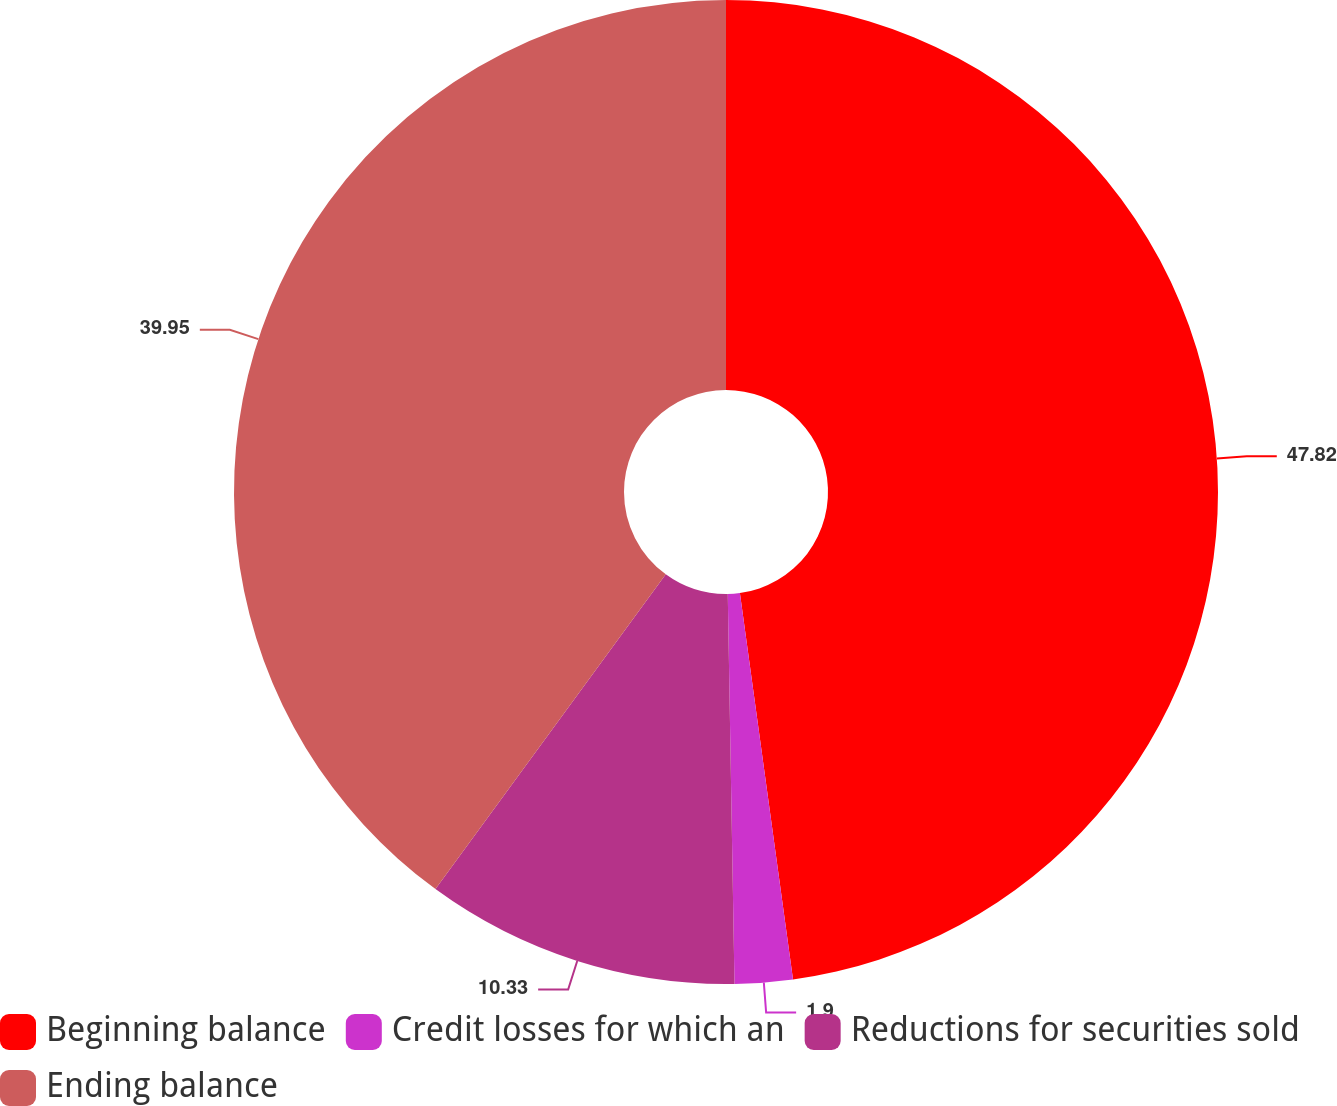Convert chart. <chart><loc_0><loc_0><loc_500><loc_500><pie_chart><fcel>Beginning balance<fcel>Credit losses for which an<fcel>Reductions for securities sold<fcel>Ending balance<nl><fcel>47.83%<fcel>1.9%<fcel>10.33%<fcel>39.95%<nl></chart> 